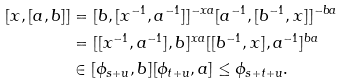Convert formula to latex. <formula><loc_0><loc_0><loc_500><loc_500>[ x , [ a , b ] ] & = [ b , [ x ^ { - 1 } , a ^ { - 1 } ] ] ^ { - x a } [ a ^ { - 1 } , [ b ^ { - 1 } , x ] ] ^ { - b a } \\ & = [ [ x ^ { - 1 } , a ^ { - 1 } ] , b ] ^ { x a } [ [ b ^ { - 1 } , x ] , a ^ { - 1 } ] ^ { b a } \\ & \in [ \phi _ { s + u } , b ] [ \phi _ { t + u } , a ] \leq \phi _ { s + t + u } .</formula> 